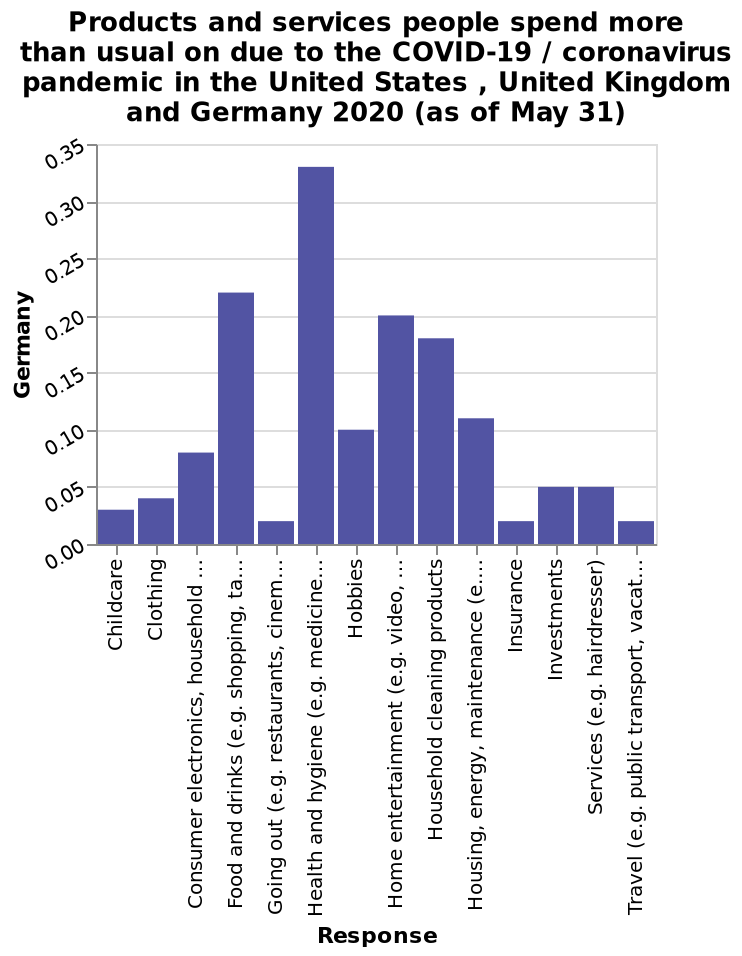<image>
What is the specific timeframe of the data represented in the bar diagram? The data in the bar diagram represents information as of May 31, 2020. Which category had the lowest sales according to the graph?  Restaurants and eating out, travel, and insurance had the lowest sales according to the graph. Which category had the highest sales according to the graph?  Health and hygiene had the highest sales according to the graph. Can you provide a reason for the low sales in restaurants and eating out, travel, and insurance? The low sales in restaurants and eating out, travel, and insurance can be attributed to the restrictions on going out and traveling due to the pandemic. What is the title of the bar diagram?  The title of the bar diagram is "Products and services people spend more than usual on due to the COVID-19 / coronavirus pandemic in the United States, United Kingdom, and Germany 2020 (as of May 31)." 